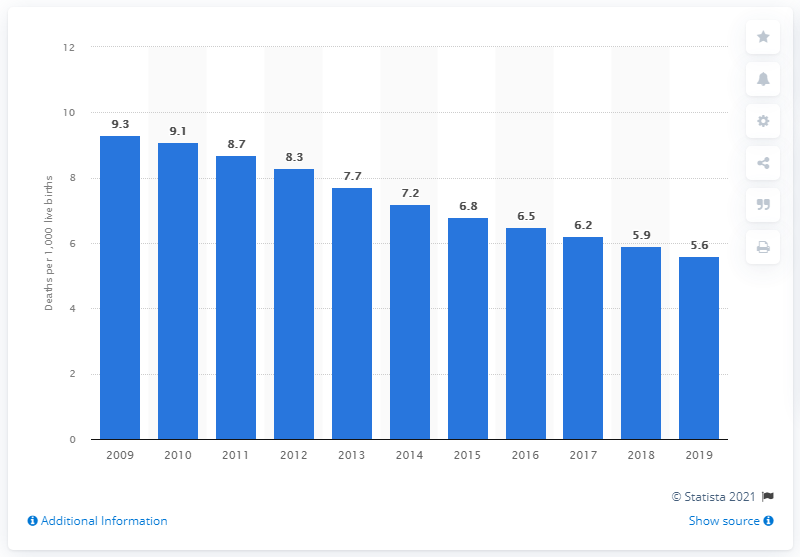Highlight a few significant elements in this photo. In 2019, the infant mortality rate in Bulgaria was 5.6 deaths per 1,000 live births. 